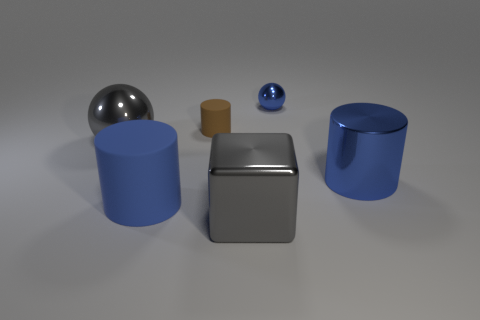Subtract all big blue metallic cylinders. How many cylinders are left? 2 Subtract all brown cylinders. How many cylinders are left? 2 Subtract 1 cubes. How many cubes are left? 0 Add 4 small green metal balls. How many objects exist? 10 Subtract all small blue metallic balls. Subtract all tiny brown matte cylinders. How many objects are left? 4 Add 5 balls. How many balls are left? 7 Add 4 blue rubber cylinders. How many blue rubber cylinders exist? 5 Subtract 0 cyan cylinders. How many objects are left? 6 Subtract all balls. How many objects are left? 4 Subtract all brown cylinders. Subtract all gray balls. How many cylinders are left? 2 